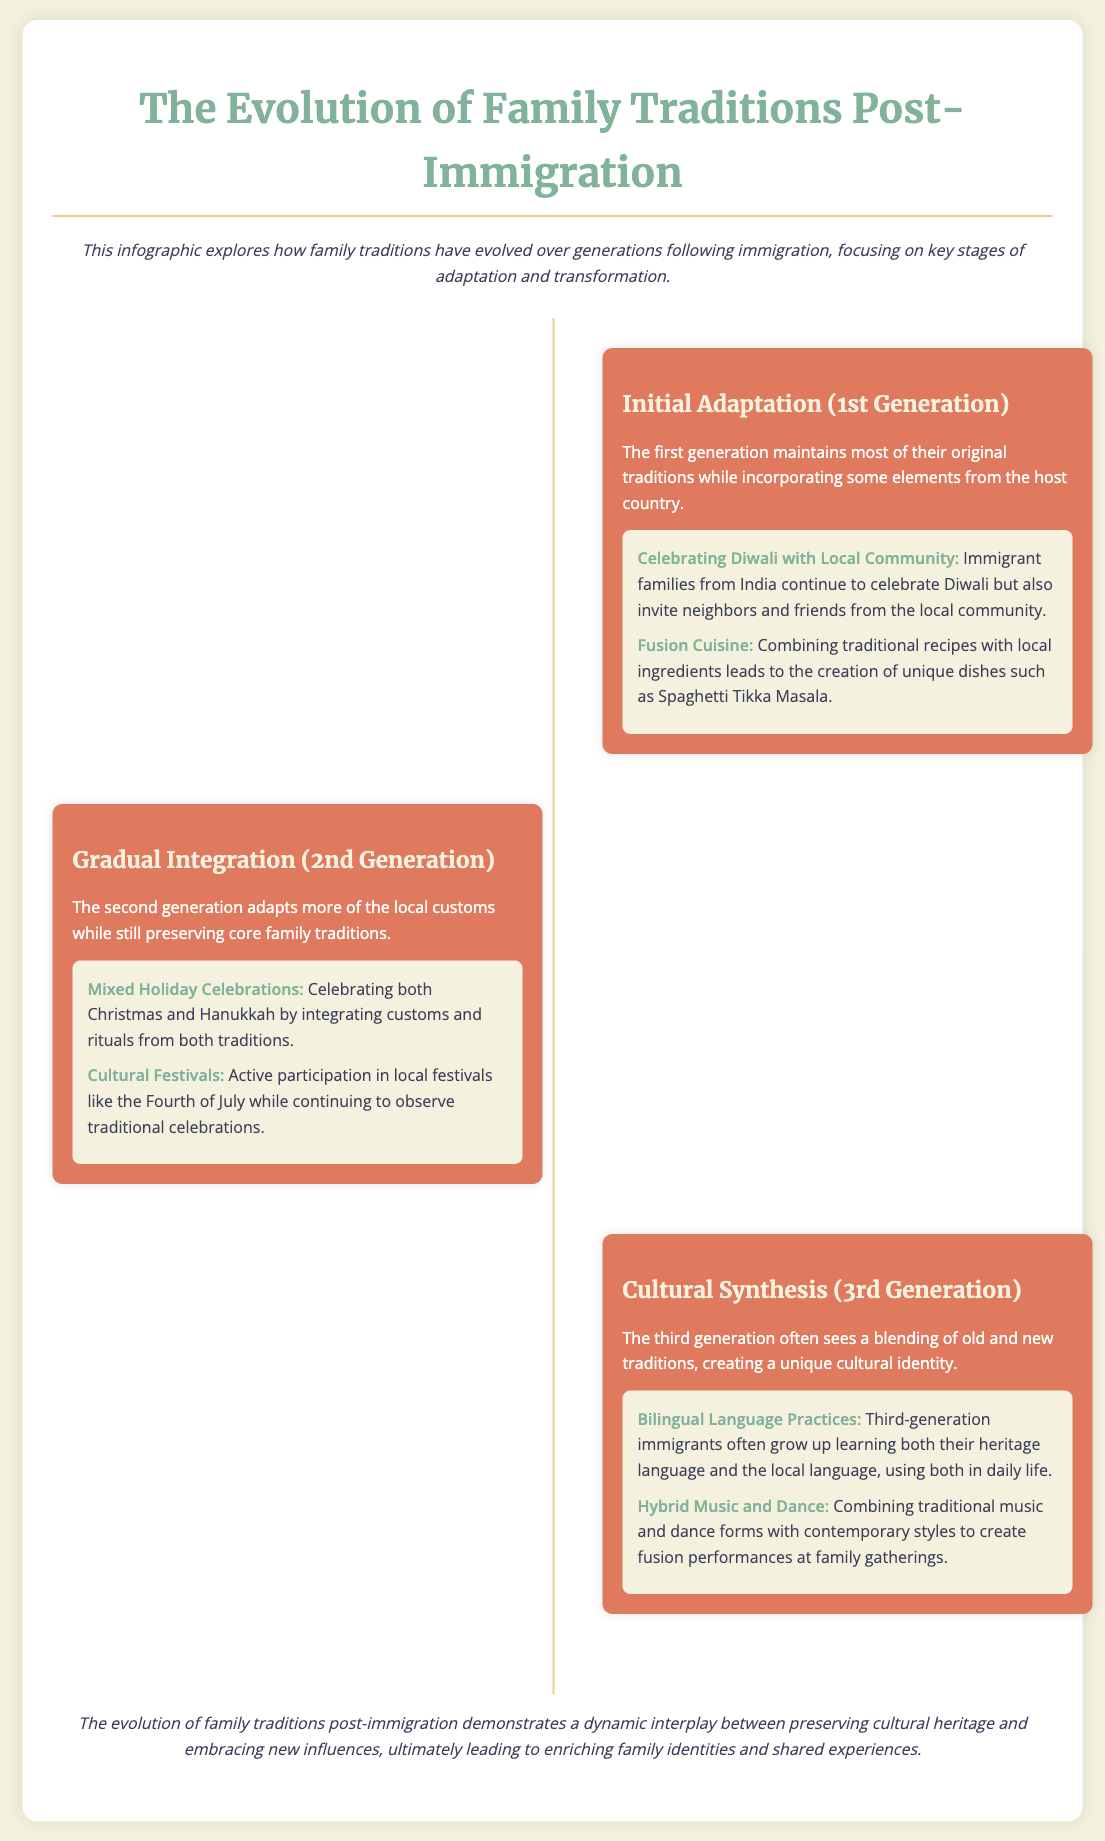what is the title of the infographic? The title of the infographic is presented at the top, indicating the main theme it covers.
Answer: The Evolution of Family Traditions Post-Immigration what is the subtitle indicating the focus of the infographic? The subtitle elaborates on what the infographic explores, mentioning key stages of adaptation and transformation after immigration.
Answer: This infographic explores how family traditions have evolved over generations following immigration which generation is associated with 'Initial Adaptation'? The section details the characteristics associated with the first generation of immigrants.
Answer: 1st Generation what are two examples from the 'Initial Adaptation' stage? The examples listed specifically under this stage provide insight into traditions being maintained and newly introduced.
Answer: Celebrating Diwali with Local Community, Fusion Cuisine what characterizes the 'Gradual Integration' phase? This phase describes how the second generation adapts and integrates local customs while keeping core family traditions alive.
Answer: Adapts more of the local customs while still preserving core family traditions what is one example from the 'Cultural Synthesis' stage? The stage provides a specific example illustrating how the third generation blends old and new traditions.
Answer: Bilingual Language Practices how does the infographic describe the evolution of family traditions post-immigration? The conclusion summarizes the overall dynamic observed in changes to family traditions over time.
Answer: A dynamic interplay between preserving cultural heritage and embracing new influences how many stages are detailed in the infographic? The document lists the various stages of evolution of family traditions, indicating a specific count.
Answer: Three stages what is the color scheme primarily used in the infographic? The use of specific colors throughout the document suggests a thematic consistency aimed at visual engagement.
Answer: Soft pastels and warm tones 